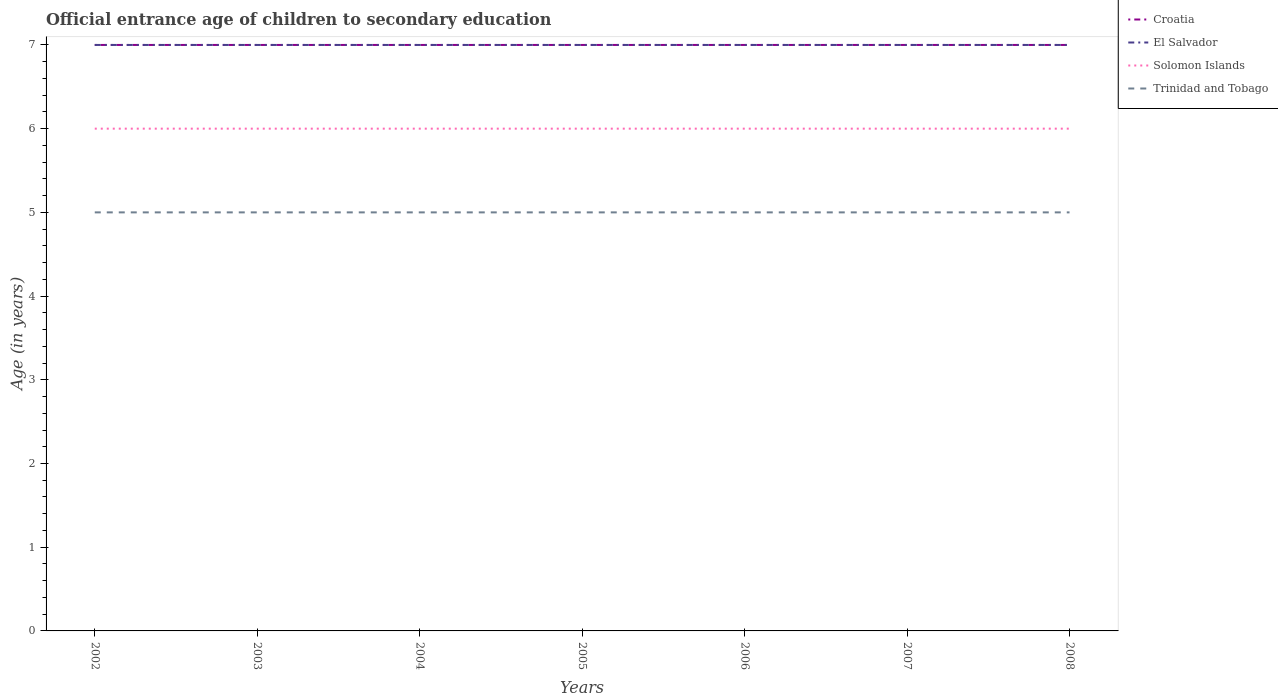Across all years, what is the maximum secondary school starting age of children in Trinidad and Tobago?
Keep it short and to the point. 5. In which year was the secondary school starting age of children in Trinidad and Tobago maximum?
Provide a short and direct response. 2002. What is the total secondary school starting age of children in Solomon Islands in the graph?
Ensure brevity in your answer.  0. What is the difference between the highest and the second highest secondary school starting age of children in El Salvador?
Keep it short and to the point. 0. Is the secondary school starting age of children in Croatia strictly greater than the secondary school starting age of children in Trinidad and Tobago over the years?
Your answer should be very brief. No. How many lines are there?
Offer a terse response. 4. How many years are there in the graph?
Make the answer very short. 7. Where does the legend appear in the graph?
Your answer should be very brief. Top right. How are the legend labels stacked?
Your answer should be very brief. Vertical. What is the title of the graph?
Offer a terse response. Official entrance age of children to secondary education. What is the label or title of the Y-axis?
Your answer should be compact. Age (in years). What is the Age (in years) of Croatia in 2002?
Your answer should be very brief. 7. What is the Age (in years) of El Salvador in 2002?
Make the answer very short. 7. What is the Age (in years) of Solomon Islands in 2002?
Provide a succinct answer. 6. What is the Age (in years) in Croatia in 2003?
Keep it short and to the point. 7. What is the Age (in years) in Solomon Islands in 2003?
Provide a short and direct response. 6. What is the Age (in years) in Trinidad and Tobago in 2003?
Your answer should be compact. 5. What is the Age (in years) in Croatia in 2004?
Give a very brief answer. 7. What is the Age (in years) of Solomon Islands in 2004?
Provide a succinct answer. 6. What is the Age (in years) in Croatia in 2005?
Keep it short and to the point. 7. What is the Age (in years) in Croatia in 2006?
Your answer should be compact. 7. What is the Age (in years) of El Salvador in 2006?
Provide a succinct answer. 7. What is the Age (in years) of Solomon Islands in 2006?
Ensure brevity in your answer.  6. What is the Age (in years) of El Salvador in 2007?
Give a very brief answer. 7. What is the Age (in years) in Solomon Islands in 2007?
Keep it short and to the point. 6. What is the Age (in years) of Croatia in 2008?
Your response must be concise. 7. What is the Age (in years) of El Salvador in 2008?
Offer a terse response. 7. What is the Age (in years) in Solomon Islands in 2008?
Offer a terse response. 6. What is the Age (in years) of Trinidad and Tobago in 2008?
Ensure brevity in your answer.  5. Across all years, what is the maximum Age (in years) in Croatia?
Make the answer very short. 7. Across all years, what is the maximum Age (in years) of El Salvador?
Your response must be concise. 7. Across all years, what is the minimum Age (in years) in El Salvador?
Give a very brief answer. 7. Across all years, what is the minimum Age (in years) of Trinidad and Tobago?
Provide a succinct answer. 5. What is the total Age (in years) of Croatia in the graph?
Your answer should be very brief. 49. What is the total Age (in years) in Trinidad and Tobago in the graph?
Ensure brevity in your answer.  35. What is the difference between the Age (in years) in Croatia in 2002 and that in 2003?
Offer a very short reply. 0. What is the difference between the Age (in years) in Solomon Islands in 2002 and that in 2003?
Offer a terse response. 0. What is the difference between the Age (in years) of Croatia in 2002 and that in 2004?
Offer a terse response. 0. What is the difference between the Age (in years) in Trinidad and Tobago in 2002 and that in 2004?
Your answer should be compact. 0. What is the difference between the Age (in years) of El Salvador in 2002 and that in 2005?
Offer a very short reply. 0. What is the difference between the Age (in years) in Trinidad and Tobago in 2002 and that in 2005?
Provide a succinct answer. 0. What is the difference between the Age (in years) of Croatia in 2002 and that in 2006?
Your answer should be compact. 0. What is the difference between the Age (in years) of El Salvador in 2002 and that in 2006?
Your answer should be very brief. 0. What is the difference between the Age (in years) of Croatia in 2002 and that in 2007?
Make the answer very short. 0. What is the difference between the Age (in years) of Solomon Islands in 2002 and that in 2007?
Offer a terse response. 0. What is the difference between the Age (in years) in Solomon Islands in 2002 and that in 2008?
Ensure brevity in your answer.  0. What is the difference between the Age (in years) of Trinidad and Tobago in 2002 and that in 2008?
Give a very brief answer. 0. What is the difference between the Age (in years) in El Salvador in 2003 and that in 2005?
Offer a very short reply. 0. What is the difference between the Age (in years) of Croatia in 2003 and that in 2006?
Make the answer very short. 0. What is the difference between the Age (in years) in El Salvador in 2003 and that in 2006?
Your response must be concise. 0. What is the difference between the Age (in years) of Solomon Islands in 2003 and that in 2006?
Your response must be concise. 0. What is the difference between the Age (in years) of Croatia in 2003 and that in 2007?
Your response must be concise. 0. What is the difference between the Age (in years) of El Salvador in 2003 and that in 2007?
Your answer should be very brief. 0. What is the difference between the Age (in years) in Trinidad and Tobago in 2003 and that in 2007?
Your answer should be very brief. 0. What is the difference between the Age (in years) in El Salvador in 2003 and that in 2008?
Make the answer very short. 0. What is the difference between the Age (in years) of Croatia in 2004 and that in 2005?
Provide a short and direct response. 0. What is the difference between the Age (in years) in Trinidad and Tobago in 2004 and that in 2005?
Offer a very short reply. 0. What is the difference between the Age (in years) of Croatia in 2004 and that in 2006?
Provide a short and direct response. 0. What is the difference between the Age (in years) of Trinidad and Tobago in 2004 and that in 2006?
Offer a very short reply. 0. What is the difference between the Age (in years) of Trinidad and Tobago in 2004 and that in 2007?
Your answer should be very brief. 0. What is the difference between the Age (in years) in El Salvador in 2004 and that in 2008?
Give a very brief answer. 0. What is the difference between the Age (in years) of Croatia in 2005 and that in 2006?
Give a very brief answer. 0. What is the difference between the Age (in years) of El Salvador in 2005 and that in 2006?
Ensure brevity in your answer.  0. What is the difference between the Age (in years) of Solomon Islands in 2005 and that in 2006?
Offer a very short reply. 0. What is the difference between the Age (in years) in Croatia in 2005 and that in 2007?
Your answer should be very brief. 0. What is the difference between the Age (in years) in El Salvador in 2005 and that in 2007?
Provide a succinct answer. 0. What is the difference between the Age (in years) of Solomon Islands in 2005 and that in 2007?
Ensure brevity in your answer.  0. What is the difference between the Age (in years) in Trinidad and Tobago in 2005 and that in 2007?
Provide a short and direct response. 0. What is the difference between the Age (in years) of Solomon Islands in 2005 and that in 2008?
Your response must be concise. 0. What is the difference between the Age (in years) of Trinidad and Tobago in 2005 and that in 2008?
Provide a succinct answer. 0. What is the difference between the Age (in years) in Croatia in 2006 and that in 2007?
Give a very brief answer. 0. What is the difference between the Age (in years) of Solomon Islands in 2006 and that in 2007?
Your response must be concise. 0. What is the difference between the Age (in years) of Trinidad and Tobago in 2006 and that in 2007?
Your response must be concise. 0. What is the difference between the Age (in years) in El Salvador in 2006 and that in 2008?
Provide a short and direct response. 0. What is the difference between the Age (in years) in Solomon Islands in 2006 and that in 2008?
Make the answer very short. 0. What is the difference between the Age (in years) of Trinidad and Tobago in 2006 and that in 2008?
Provide a succinct answer. 0. What is the difference between the Age (in years) in El Salvador in 2007 and that in 2008?
Your response must be concise. 0. What is the difference between the Age (in years) in Solomon Islands in 2007 and that in 2008?
Offer a terse response. 0. What is the difference between the Age (in years) in Croatia in 2002 and the Age (in years) in El Salvador in 2003?
Make the answer very short. 0. What is the difference between the Age (in years) in El Salvador in 2002 and the Age (in years) in Solomon Islands in 2004?
Offer a very short reply. 1. What is the difference between the Age (in years) in Croatia in 2002 and the Age (in years) in Solomon Islands in 2005?
Make the answer very short. 1. What is the difference between the Age (in years) of Croatia in 2002 and the Age (in years) of Trinidad and Tobago in 2005?
Keep it short and to the point. 2. What is the difference between the Age (in years) in El Salvador in 2002 and the Age (in years) in Solomon Islands in 2005?
Offer a very short reply. 1. What is the difference between the Age (in years) in El Salvador in 2002 and the Age (in years) in Trinidad and Tobago in 2005?
Your response must be concise. 2. What is the difference between the Age (in years) in Solomon Islands in 2002 and the Age (in years) in Trinidad and Tobago in 2005?
Your answer should be very brief. 1. What is the difference between the Age (in years) of Croatia in 2002 and the Age (in years) of Solomon Islands in 2006?
Ensure brevity in your answer.  1. What is the difference between the Age (in years) in El Salvador in 2002 and the Age (in years) in Solomon Islands in 2006?
Give a very brief answer. 1. What is the difference between the Age (in years) of El Salvador in 2002 and the Age (in years) of Trinidad and Tobago in 2006?
Ensure brevity in your answer.  2. What is the difference between the Age (in years) in Solomon Islands in 2002 and the Age (in years) in Trinidad and Tobago in 2006?
Offer a terse response. 1. What is the difference between the Age (in years) in Croatia in 2002 and the Age (in years) in El Salvador in 2007?
Your answer should be very brief. 0. What is the difference between the Age (in years) of Croatia in 2002 and the Age (in years) of Solomon Islands in 2007?
Offer a very short reply. 1. What is the difference between the Age (in years) in Croatia in 2002 and the Age (in years) in Trinidad and Tobago in 2007?
Your answer should be very brief. 2. What is the difference between the Age (in years) in El Salvador in 2002 and the Age (in years) in Solomon Islands in 2007?
Offer a very short reply. 1. What is the difference between the Age (in years) of El Salvador in 2002 and the Age (in years) of Trinidad and Tobago in 2007?
Ensure brevity in your answer.  2. What is the difference between the Age (in years) of Solomon Islands in 2002 and the Age (in years) of Trinidad and Tobago in 2007?
Give a very brief answer. 1. What is the difference between the Age (in years) in Croatia in 2002 and the Age (in years) in El Salvador in 2008?
Keep it short and to the point. 0. What is the difference between the Age (in years) of Croatia in 2002 and the Age (in years) of Trinidad and Tobago in 2008?
Make the answer very short. 2. What is the difference between the Age (in years) in El Salvador in 2002 and the Age (in years) in Solomon Islands in 2008?
Ensure brevity in your answer.  1. What is the difference between the Age (in years) in Solomon Islands in 2002 and the Age (in years) in Trinidad and Tobago in 2008?
Ensure brevity in your answer.  1. What is the difference between the Age (in years) in Croatia in 2003 and the Age (in years) in El Salvador in 2004?
Give a very brief answer. 0. What is the difference between the Age (in years) in Solomon Islands in 2003 and the Age (in years) in Trinidad and Tobago in 2004?
Offer a terse response. 1. What is the difference between the Age (in years) of Croatia in 2003 and the Age (in years) of Solomon Islands in 2005?
Your answer should be very brief. 1. What is the difference between the Age (in years) in El Salvador in 2003 and the Age (in years) in Solomon Islands in 2005?
Keep it short and to the point. 1. What is the difference between the Age (in years) in Croatia in 2003 and the Age (in years) in Solomon Islands in 2006?
Keep it short and to the point. 1. What is the difference between the Age (in years) in Croatia in 2003 and the Age (in years) in Trinidad and Tobago in 2006?
Give a very brief answer. 2. What is the difference between the Age (in years) of El Salvador in 2003 and the Age (in years) of Solomon Islands in 2006?
Offer a terse response. 1. What is the difference between the Age (in years) in Solomon Islands in 2003 and the Age (in years) in Trinidad and Tobago in 2006?
Your answer should be compact. 1. What is the difference between the Age (in years) of Croatia in 2003 and the Age (in years) of El Salvador in 2007?
Your answer should be compact. 0. What is the difference between the Age (in years) of Croatia in 2003 and the Age (in years) of Solomon Islands in 2007?
Your answer should be very brief. 1. What is the difference between the Age (in years) in Croatia in 2003 and the Age (in years) in Trinidad and Tobago in 2007?
Your answer should be compact. 2. What is the difference between the Age (in years) in Solomon Islands in 2003 and the Age (in years) in Trinidad and Tobago in 2007?
Keep it short and to the point. 1. What is the difference between the Age (in years) in Croatia in 2003 and the Age (in years) in Trinidad and Tobago in 2008?
Make the answer very short. 2. What is the difference between the Age (in years) in Solomon Islands in 2003 and the Age (in years) in Trinidad and Tobago in 2008?
Your response must be concise. 1. What is the difference between the Age (in years) of Croatia in 2004 and the Age (in years) of Solomon Islands in 2005?
Offer a terse response. 1. What is the difference between the Age (in years) in El Salvador in 2004 and the Age (in years) in Trinidad and Tobago in 2005?
Provide a succinct answer. 2. What is the difference between the Age (in years) of Solomon Islands in 2004 and the Age (in years) of Trinidad and Tobago in 2005?
Your response must be concise. 1. What is the difference between the Age (in years) of Croatia in 2004 and the Age (in years) of El Salvador in 2006?
Your answer should be compact. 0. What is the difference between the Age (in years) of Croatia in 2004 and the Age (in years) of Solomon Islands in 2006?
Provide a short and direct response. 1. What is the difference between the Age (in years) of Croatia in 2004 and the Age (in years) of Trinidad and Tobago in 2006?
Your response must be concise. 2. What is the difference between the Age (in years) in El Salvador in 2004 and the Age (in years) in Trinidad and Tobago in 2006?
Make the answer very short. 2. What is the difference between the Age (in years) in Croatia in 2004 and the Age (in years) in El Salvador in 2007?
Ensure brevity in your answer.  0. What is the difference between the Age (in years) in Croatia in 2004 and the Age (in years) in Solomon Islands in 2007?
Keep it short and to the point. 1. What is the difference between the Age (in years) of El Salvador in 2004 and the Age (in years) of Solomon Islands in 2007?
Make the answer very short. 1. What is the difference between the Age (in years) in El Salvador in 2004 and the Age (in years) in Trinidad and Tobago in 2007?
Give a very brief answer. 2. What is the difference between the Age (in years) of Croatia in 2004 and the Age (in years) of Trinidad and Tobago in 2008?
Offer a very short reply. 2. What is the difference between the Age (in years) in El Salvador in 2004 and the Age (in years) in Solomon Islands in 2008?
Keep it short and to the point. 1. What is the difference between the Age (in years) in Solomon Islands in 2004 and the Age (in years) in Trinidad and Tobago in 2008?
Your answer should be compact. 1. What is the difference between the Age (in years) of Croatia in 2005 and the Age (in years) of El Salvador in 2006?
Your response must be concise. 0. What is the difference between the Age (in years) of Croatia in 2005 and the Age (in years) of Solomon Islands in 2006?
Your answer should be compact. 1. What is the difference between the Age (in years) in El Salvador in 2005 and the Age (in years) in Solomon Islands in 2006?
Your answer should be very brief. 1. What is the difference between the Age (in years) of Solomon Islands in 2005 and the Age (in years) of Trinidad and Tobago in 2006?
Keep it short and to the point. 1. What is the difference between the Age (in years) of Croatia in 2005 and the Age (in years) of Trinidad and Tobago in 2007?
Provide a short and direct response. 2. What is the difference between the Age (in years) in El Salvador in 2005 and the Age (in years) in Solomon Islands in 2007?
Your answer should be very brief. 1. What is the difference between the Age (in years) in El Salvador in 2005 and the Age (in years) in Trinidad and Tobago in 2007?
Provide a succinct answer. 2. What is the difference between the Age (in years) of Croatia in 2005 and the Age (in years) of Solomon Islands in 2008?
Your response must be concise. 1. What is the difference between the Age (in years) of Croatia in 2005 and the Age (in years) of Trinidad and Tobago in 2008?
Provide a succinct answer. 2. What is the difference between the Age (in years) of El Salvador in 2005 and the Age (in years) of Trinidad and Tobago in 2008?
Keep it short and to the point. 2. What is the difference between the Age (in years) in Croatia in 2006 and the Age (in years) in Solomon Islands in 2007?
Keep it short and to the point. 1. What is the difference between the Age (in years) in El Salvador in 2006 and the Age (in years) in Solomon Islands in 2007?
Make the answer very short. 1. What is the difference between the Age (in years) in Croatia in 2006 and the Age (in years) in El Salvador in 2008?
Ensure brevity in your answer.  0. What is the difference between the Age (in years) of Croatia in 2006 and the Age (in years) of Solomon Islands in 2008?
Offer a terse response. 1. What is the difference between the Age (in years) of El Salvador in 2006 and the Age (in years) of Trinidad and Tobago in 2008?
Make the answer very short. 2. What is the difference between the Age (in years) of Solomon Islands in 2006 and the Age (in years) of Trinidad and Tobago in 2008?
Provide a succinct answer. 1. What is the difference between the Age (in years) of Croatia in 2007 and the Age (in years) of El Salvador in 2008?
Your response must be concise. 0. What is the difference between the Age (in years) in Croatia in 2007 and the Age (in years) in Solomon Islands in 2008?
Offer a terse response. 1. What is the average Age (in years) of Croatia per year?
Your answer should be compact. 7. In the year 2002, what is the difference between the Age (in years) in Croatia and Age (in years) in El Salvador?
Give a very brief answer. 0. In the year 2002, what is the difference between the Age (in years) in Croatia and Age (in years) in Solomon Islands?
Your answer should be compact. 1. In the year 2002, what is the difference between the Age (in years) of Croatia and Age (in years) of Trinidad and Tobago?
Provide a short and direct response. 2. In the year 2002, what is the difference between the Age (in years) of El Salvador and Age (in years) of Solomon Islands?
Offer a terse response. 1. In the year 2002, what is the difference between the Age (in years) of El Salvador and Age (in years) of Trinidad and Tobago?
Make the answer very short. 2. In the year 2002, what is the difference between the Age (in years) in Solomon Islands and Age (in years) in Trinidad and Tobago?
Your answer should be very brief. 1. In the year 2003, what is the difference between the Age (in years) of Croatia and Age (in years) of Solomon Islands?
Give a very brief answer. 1. In the year 2003, what is the difference between the Age (in years) in Croatia and Age (in years) in Trinidad and Tobago?
Offer a terse response. 2. In the year 2003, what is the difference between the Age (in years) of El Salvador and Age (in years) of Solomon Islands?
Make the answer very short. 1. In the year 2003, what is the difference between the Age (in years) in El Salvador and Age (in years) in Trinidad and Tobago?
Your answer should be very brief. 2. In the year 2005, what is the difference between the Age (in years) in Croatia and Age (in years) in El Salvador?
Your answer should be compact. 0. In the year 2005, what is the difference between the Age (in years) of Croatia and Age (in years) of Solomon Islands?
Your answer should be very brief. 1. In the year 2005, what is the difference between the Age (in years) of Croatia and Age (in years) of Trinidad and Tobago?
Provide a succinct answer. 2. In the year 2005, what is the difference between the Age (in years) in El Salvador and Age (in years) in Trinidad and Tobago?
Provide a short and direct response. 2. In the year 2006, what is the difference between the Age (in years) in Croatia and Age (in years) in El Salvador?
Ensure brevity in your answer.  0. In the year 2006, what is the difference between the Age (in years) of El Salvador and Age (in years) of Trinidad and Tobago?
Offer a terse response. 2. In the year 2006, what is the difference between the Age (in years) of Solomon Islands and Age (in years) of Trinidad and Tobago?
Ensure brevity in your answer.  1. In the year 2007, what is the difference between the Age (in years) in Croatia and Age (in years) in El Salvador?
Your answer should be compact. 0. In the year 2007, what is the difference between the Age (in years) in Croatia and Age (in years) in Solomon Islands?
Make the answer very short. 1. In the year 2007, what is the difference between the Age (in years) of Croatia and Age (in years) of Trinidad and Tobago?
Offer a very short reply. 2. In the year 2007, what is the difference between the Age (in years) in El Salvador and Age (in years) in Solomon Islands?
Make the answer very short. 1. In the year 2008, what is the difference between the Age (in years) in Croatia and Age (in years) in El Salvador?
Give a very brief answer. 0. In the year 2008, what is the difference between the Age (in years) of Croatia and Age (in years) of Trinidad and Tobago?
Give a very brief answer. 2. In the year 2008, what is the difference between the Age (in years) in Solomon Islands and Age (in years) in Trinidad and Tobago?
Offer a terse response. 1. What is the ratio of the Age (in years) of El Salvador in 2002 to that in 2003?
Give a very brief answer. 1. What is the ratio of the Age (in years) in Croatia in 2002 to that in 2004?
Your answer should be very brief. 1. What is the ratio of the Age (in years) in Solomon Islands in 2002 to that in 2004?
Your answer should be compact. 1. What is the ratio of the Age (in years) in Croatia in 2002 to that in 2005?
Give a very brief answer. 1. What is the ratio of the Age (in years) in El Salvador in 2002 to that in 2005?
Offer a very short reply. 1. What is the ratio of the Age (in years) of Solomon Islands in 2002 to that in 2005?
Your answer should be compact. 1. What is the ratio of the Age (in years) in Croatia in 2002 to that in 2006?
Provide a succinct answer. 1. What is the ratio of the Age (in years) of El Salvador in 2002 to that in 2006?
Your response must be concise. 1. What is the ratio of the Age (in years) in Solomon Islands in 2002 to that in 2006?
Make the answer very short. 1. What is the ratio of the Age (in years) in Trinidad and Tobago in 2002 to that in 2006?
Provide a short and direct response. 1. What is the ratio of the Age (in years) in El Salvador in 2002 to that in 2007?
Give a very brief answer. 1. What is the ratio of the Age (in years) of Solomon Islands in 2002 to that in 2007?
Offer a very short reply. 1. What is the ratio of the Age (in years) in El Salvador in 2002 to that in 2008?
Provide a short and direct response. 1. What is the ratio of the Age (in years) of Solomon Islands in 2003 to that in 2004?
Your answer should be very brief. 1. What is the ratio of the Age (in years) in Solomon Islands in 2003 to that in 2006?
Offer a very short reply. 1. What is the ratio of the Age (in years) in Trinidad and Tobago in 2003 to that in 2006?
Offer a terse response. 1. What is the ratio of the Age (in years) of Croatia in 2003 to that in 2007?
Make the answer very short. 1. What is the ratio of the Age (in years) in Solomon Islands in 2003 to that in 2007?
Offer a very short reply. 1. What is the ratio of the Age (in years) in Solomon Islands in 2003 to that in 2008?
Offer a terse response. 1. What is the ratio of the Age (in years) of Trinidad and Tobago in 2003 to that in 2008?
Keep it short and to the point. 1. What is the ratio of the Age (in years) in Croatia in 2004 to that in 2005?
Provide a short and direct response. 1. What is the ratio of the Age (in years) of El Salvador in 2004 to that in 2005?
Ensure brevity in your answer.  1. What is the ratio of the Age (in years) of Solomon Islands in 2004 to that in 2005?
Offer a very short reply. 1. What is the ratio of the Age (in years) of Trinidad and Tobago in 2004 to that in 2005?
Make the answer very short. 1. What is the ratio of the Age (in years) of El Salvador in 2004 to that in 2006?
Provide a short and direct response. 1. What is the ratio of the Age (in years) in Solomon Islands in 2004 to that in 2006?
Your response must be concise. 1. What is the ratio of the Age (in years) of Trinidad and Tobago in 2004 to that in 2007?
Provide a succinct answer. 1. What is the ratio of the Age (in years) of Croatia in 2004 to that in 2008?
Ensure brevity in your answer.  1. What is the ratio of the Age (in years) of Solomon Islands in 2004 to that in 2008?
Keep it short and to the point. 1. What is the ratio of the Age (in years) in Trinidad and Tobago in 2005 to that in 2006?
Your answer should be very brief. 1. What is the ratio of the Age (in years) of Croatia in 2005 to that in 2007?
Make the answer very short. 1. What is the ratio of the Age (in years) in Solomon Islands in 2005 to that in 2007?
Provide a short and direct response. 1. What is the ratio of the Age (in years) of Trinidad and Tobago in 2005 to that in 2007?
Offer a terse response. 1. What is the ratio of the Age (in years) of El Salvador in 2005 to that in 2008?
Make the answer very short. 1. What is the ratio of the Age (in years) in Croatia in 2006 to that in 2007?
Make the answer very short. 1. What is the ratio of the Age (in years) of Solomon Islands in 2006 to that in 2007?
Keep it short and to the point. 1. What is the ratio of the Age (in years) in Trinidad and Tobago in 2006 to that in 2007?
Offer a very short reply. 1. What is the ratio of the Age (in years) in Croatia in 2006 to that in 2008?
Your answer should be compact. 1. What is the ratio of the Age (in years) of Trinidad and Tobago in 2007 to that in 2008?
Provide a short and direct response. 1. What is the difference between the highest and the second highest Age (in years) in Croatia?
Keep it short and to the point. 0. What is the difference between the highest and the second highest Age (in years) in El Salvador?
Offer a very short reply. 0. What is the difference between the highest and the second highest Age (in years) of Solomon Islands?
Give a very brief answer. 0. What is the difference between the highest and the second highest Age (in years) in Trinidad and Tobago?
Your answer should be very brief. 0. What is the difference between the highest and the lowest Age (in years) in Croatia?
Your answer should be very brief. 0. What is the difference between the highest and the lowest Age (in years) of El Salvador?
Offer a terse response. 0. What is the difference between the highest and the lowest Age (in years) in Solomon Islands?
Your answer should be compact. 0. What is the difference between the highest and the lowest Age (in years) of Trinidad and Tobago?
Provide a succinct answer. 0. 